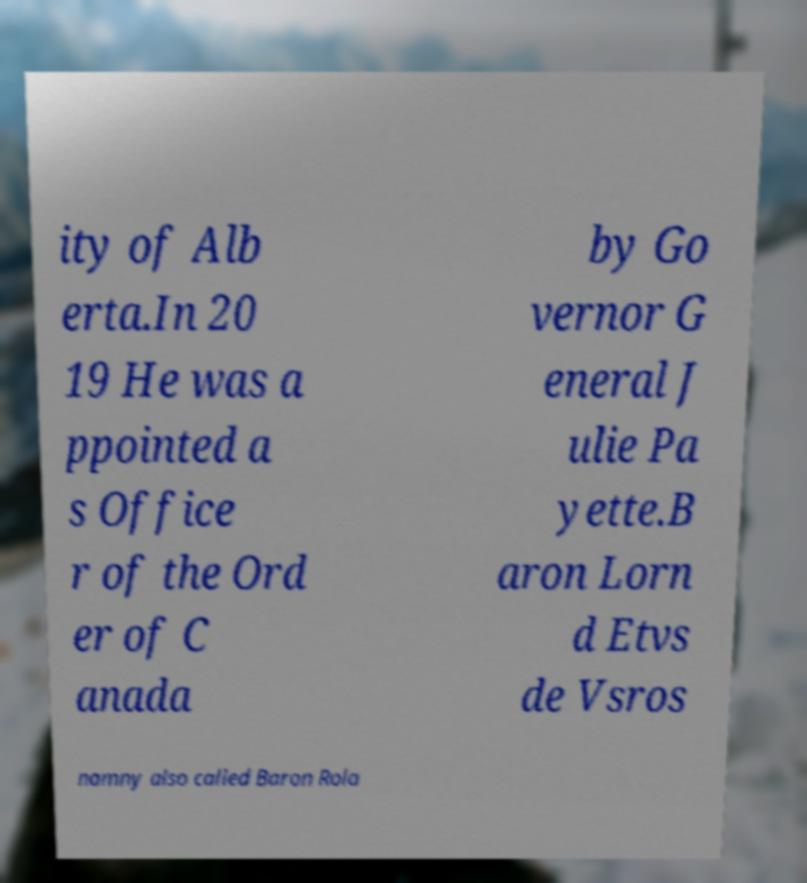Please identify and transcribe the text found in this image. ity of Alb erta.In 20 19 He was a ppointed a s Office r of the Ord er of C anada by Go vernor G eneral J ulie Pa yette.B aron Lorn d Etvs de Vsros namny also called Baron Rola 